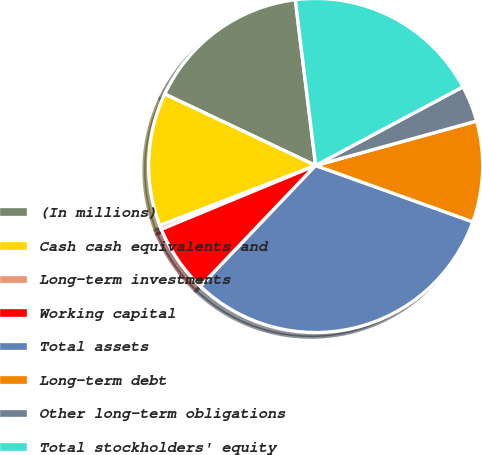Convert chart. <chart><loc_0><loc_0><loc_500><loc_500><pie_chart><fcel>(In millions)<fcel>Cash cash equivalents and<fcel>Long-term investments<fcel>Working capital<fcel>Total assets<fcel>Long-term debt<fcel>Other long-term obligations<fcel>Total stockholders' equity<nl><fcel>16.02%<fcel>12.89%<fcel>0.39%<fcel>6.64%<fcel>31.64%<fcel>9.77%<fcel>3.52%<fcel>19.14%<nl></chart> 